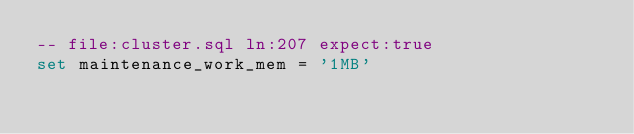Convert code to text. <code><loc_0><loc_0><loc_500><loc_500><_SQL_>-- file:cluster.sql ln:207 expect:true
set maintenance_work_mem = '1MB'
</code> 